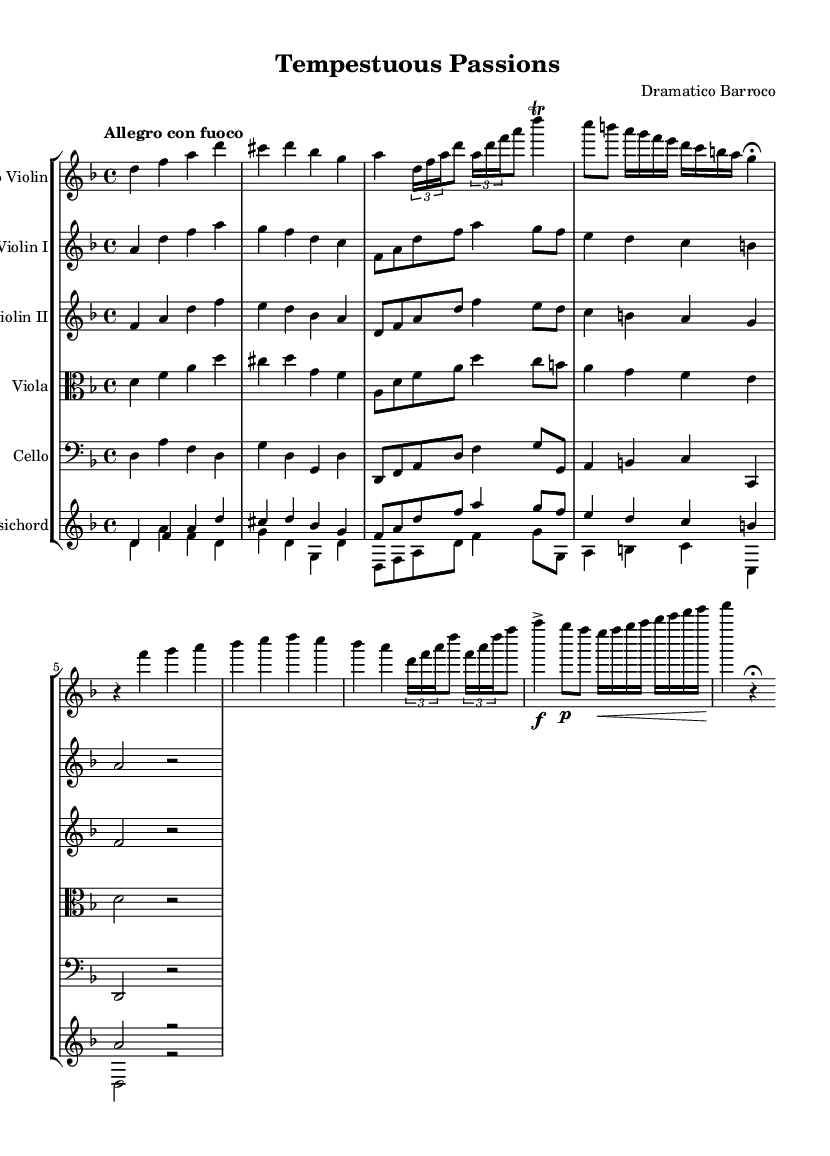What is the key signature of this music? The key signature is indicated at the beginning of the sheet music, showing 1 flat, which means it is in D minor.
Answer: D minor What is the time signature of this piece? The time signature is found at the beginning of the sheet music, with the upper number as 4 and the lower number as 4, indicating it is in 4/4 time.
Answer: 4/4 What is the tempo marking of this concerto? The tempo marking is directly stated at the beginning of the score, which reads "Allegro con fuoco," indicating a fast and fiery tempo.
Answer: Allegro con fuoco How many measures are there in the solo violin part? Counting the measures in the solo violin part, we determine there are 8 measures in total from the start to the end of the section.
Answer: 8 measures What is the highest note in the violin solo? By examining the notes written in the solo violin staff, the highest note is identified as the note A, which appears several times throughout the part.
Answer: A What unique Baroque feature is highlighted in the solo? The solo violin part contains multiple trills, a common ornamentation in Baroque music, specifically seen in one of the measures.
Answer: Trills What is the texture of the ensemble during the solo violin sections? Analyzing the score, the texture is primarily homophonic, with the solo violin clearly leading while the other instruments provide harmonic support.
Answer: Homophonic 